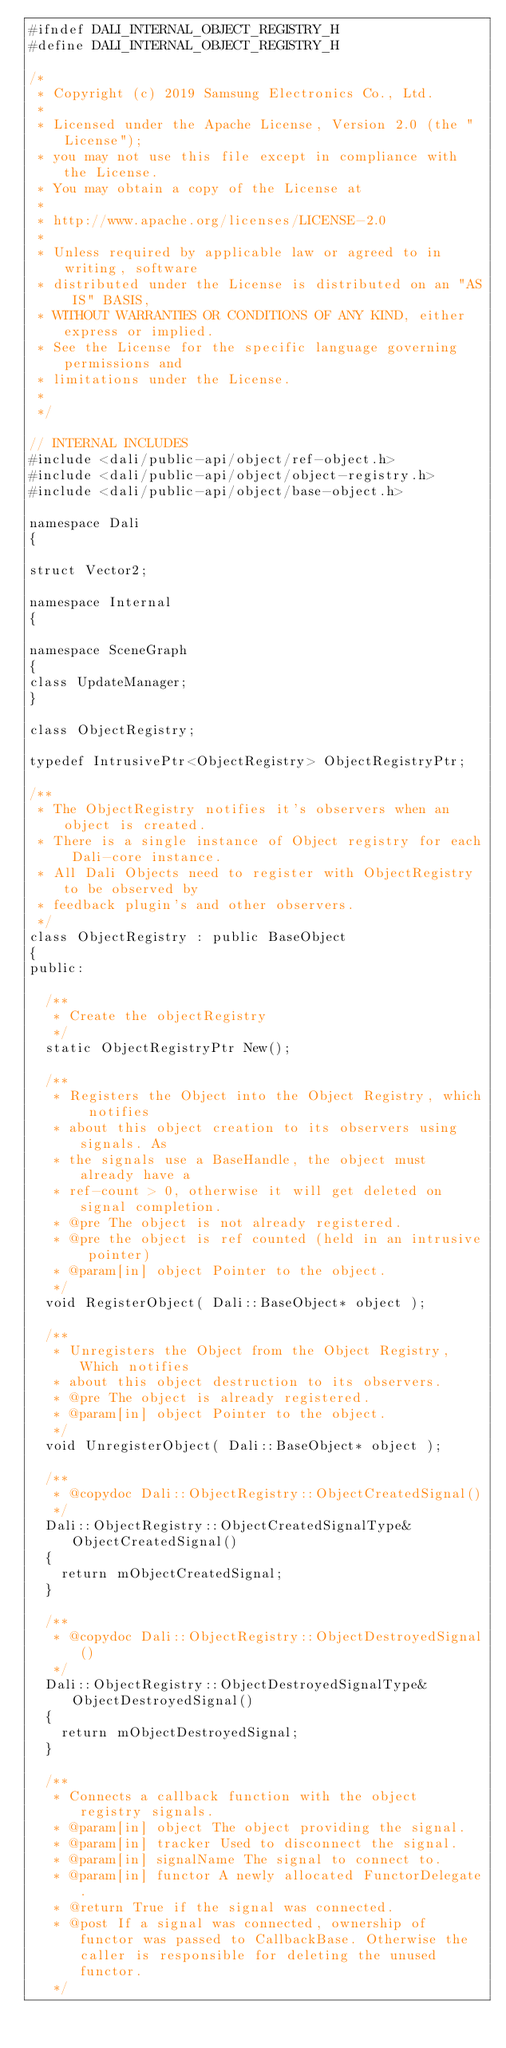Convert code to text. <code><loc_0><loc_0><loc_500><loc_500><_C_>#ifndef DALI_INTERNAL_OBJECT_REGISTRY_H
#define DALI_INTERNAL_OBJECT_REGISTRY_H

/*
 * Copyright (c) 2019 Samsung Electronics Co., Ltd.
 *
 * Licensed under the Apache License, Version 2.0 (the "License");
 * you may not use this file except in compliance with the License.
 * You may obtain a copy of the License at
 *
 * http://www.apache.org/licenses/LICENSE-2.0
 *
 * Unless required by applicable law or agreed to in writing, software
 * distributed under the License is distributed on an "AS IS" BASIS,
 * WITHOUT WARRANTIES OR CONDITIONS OF ANY KIND, either express or implied.
 * See the License for the specific language governing permissions and
 * limitations under the License.
 *
 */

// INTERNAL INCLUDES
#include <dali/public-api/object/ref-object.h>
#include <dali/public-api/object/object-registry.h>
#include <dali/public-api/object/base-object.h>

namespace Dali
{

struct Vector2;

namespace Internal
{

namespace SceneGraph
{
class UpdateManager;
}

class ObjectRegistry;

typedef IntrusivePtr<ObjectRegistry> ObjectRegistryPtr;

/**
 * The ObjectRegistry notifies it's observers when an object is created.
 * There is a single instance of Object registry for each Dali-core instance.
 * All Dali Objects need to register with ObjectRegistry to be observed by
 * feedback plugin's and other observers.
 */
class ObjectRegistry : public BaseObject
{
public:

  /**
   * Create the objectRegistry
   */
  static ObjectRegistryPtr New();

  /**
   * Registers the Object into the Object Registry, which notifies
   * about this object creation to its observers using signals. As
   * the signals use a BaseHandle, the object must already have a
   * ref-count > 0, otherwise it will get deleted on signal completion.
   * @pre The object is not already registered.
   * @pre the object is ref counted (held in an intrusive pointer)
   * @param[in] object Pointer to the object.
   */
  void RegisterObject( Dali::BaseObject* object );

  /**
   * Unregisters the Object from the Object Registry, Which notifies
   * about this object destruction to its observers.
   * @pre The object is already registered.
   * @param[in] object Pointer to the object.
   */
  void UnregisterObject( Dali::BaseObject* object );

  /**
   * @copydoc Dali::ObjectRegistry::ObjectCreatedSignal()
   */
  Dali::ObjectRegistry::ObjectCreatedSignalType& ObjectCreatedSignal()
  {
    return mObjectCreatedSignal;
  }

  /**
   * @copydoc Dali::ObjectRegistry::ObjectDestroyedSignal()
   */
  Dali::ObjectRegistry::ObjectDestroyedSignalType& ObjectDestroyedSignal()
  {
    return mObjectDestroyedSignal;
  }

  /**
   * Connects a callback function with the object registry signals.
   * @param[in] object The object providing the signal.
   * @param[in] tracker Used to disconnect the signal.
   * @param[in] signalName The signal to connect to.
   * @param[in] functor A newly allocated FunctorDelegate.
   * @return True if the signal was connected.
   * @post If a signal was connected, ownership of functor was passed to CallbackBase. Otherwise the caller is responsible for deleting the unused functor.
   */</code> 